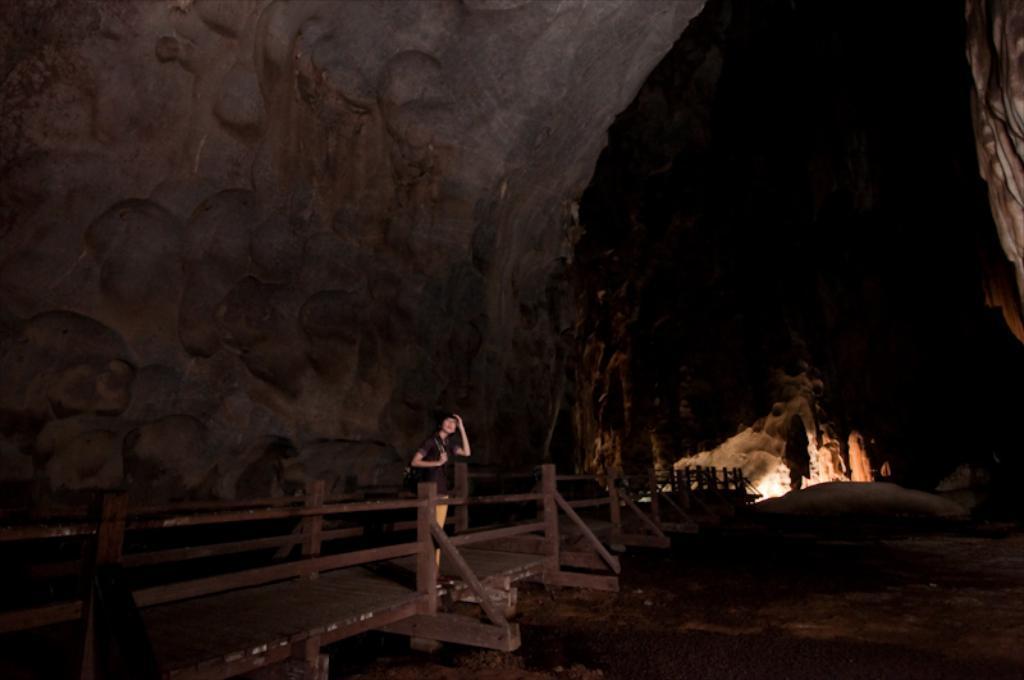Could you give a brief overview of what you see in this image? In the picture I can see a person is standing. In the background I can see fence, lights and some other objects on the ground. This image is little bit dark. 